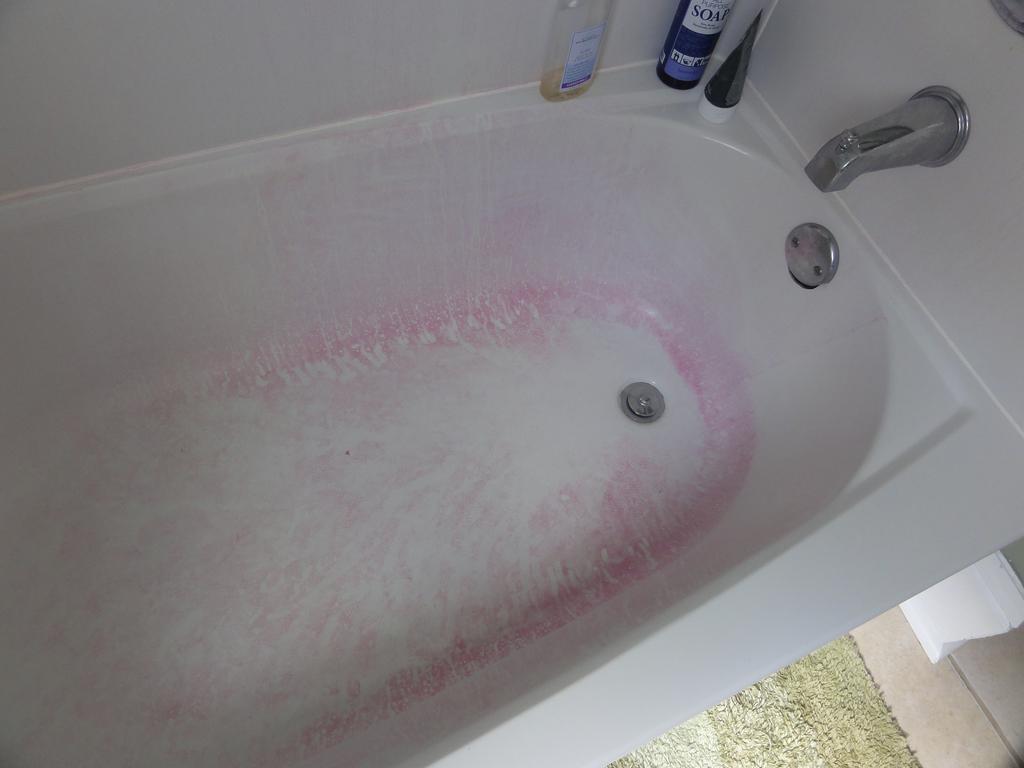Could you give a brief overview of what you see in this image? In this image there is a bathtub. On the bathtub there is a tap. There are shampoo bottles. At the bottom of the image there is a mat on the floor. There is a paper napkin. 